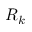Convert formula to latex. <formula><loc_0><loc_0><loc_500><loc_500>R _ { k }</formula> 